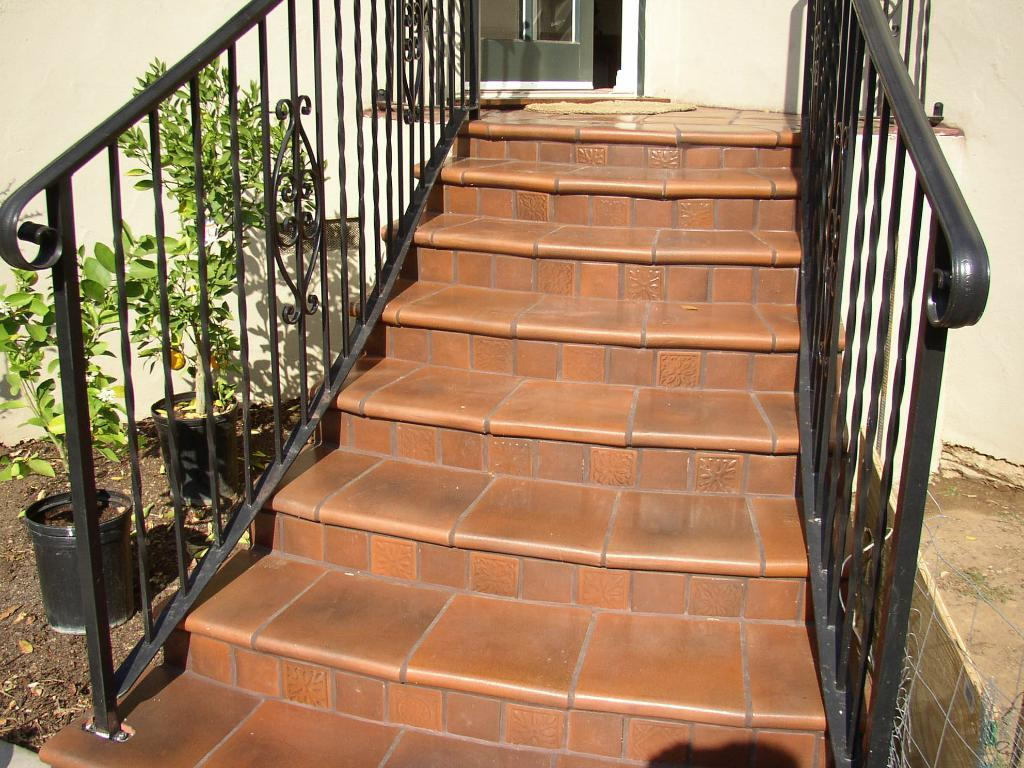What type of structure is present in the image? There are stairs in the image. What can be found near the stairs? There are pots in the image. What is inside the pots? The pots contain plants. How many kittens are playing with the lace on the stairs? There are no kittens or lace present in the image. 